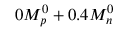Convert formula to latex. <formula><loc_0><loc_0><loc_500><loc_500>0 M _ { p } ^ { 0 } + 0 . 4 M _ { n } ^ { 0 }</formula> 